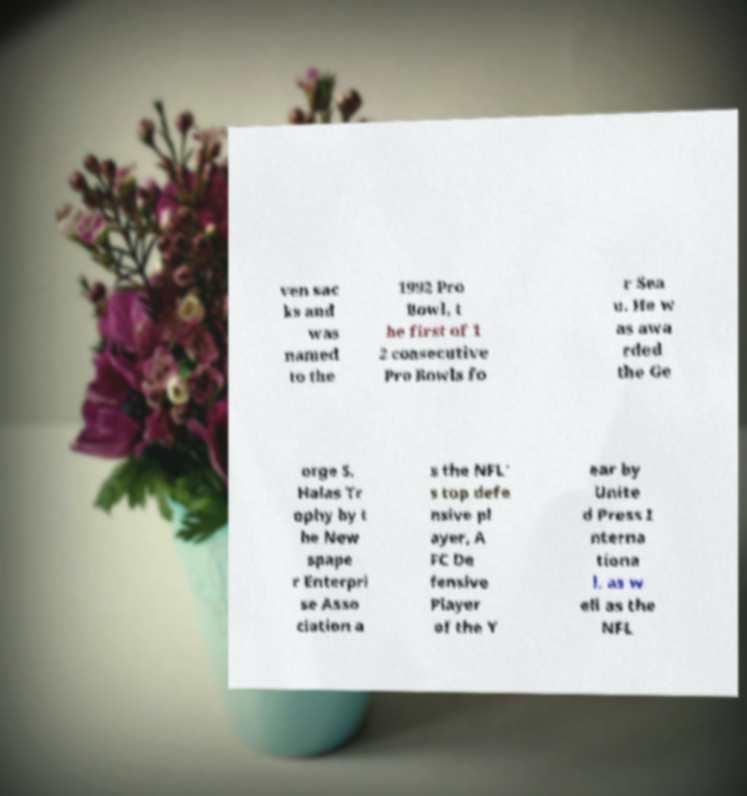Could you extract and type out the text from this image? ven sac ks and was named to the 1992 Pro Bowl, t he first of 1 2 consecutive Pro Bowls fo r Sea u. He w as awa rded the Ge orge S. Halas Tr ophy by t he New spape r Enterpri se Asso ciation a s the NFL' s top defe nsive pl ayer, A FC De fensive Player of the Y ear by Unite d Press I nterna tiona l, as w ell as the NFL 